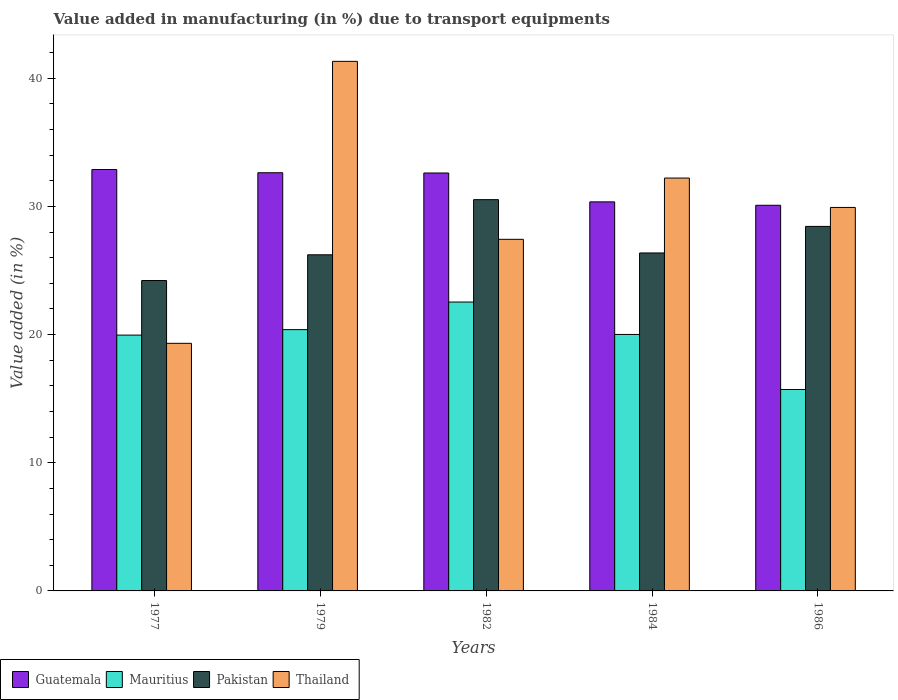How many different coloured bars are there?
Offer a very short reply. 4. How many groups of bars are there?
Offer a terse response. 5. Are the number of bars on each tick of the X-axis equal?
Offer a terse response. Yes. How many bars are there on the 2nd tick from the left?
Ensure brevity in your answer.  4. In how many cases, is the number of bars for a given year not equal to the number of legend labels?
Offer a very short reply. 0. What is the percentage of value added in manufacturing due to transport equipments in Mauritius in 1977?
Give a very brief answer. 19.96. Across all years, what is the maximum percentage of value added in manufacturing due to transport equipments in Guatemala?
Offer a very short reply. 32.88. Across all years, what is the minimum percentage of value added in manufacturing due to transport equipments in Guatemala?
Ensure brevity in your answer.  30.09. In which year was the percentage of value added in manufacturing due to transport equipments in Pakistan minimum?
Your response must be concise. 1977. What is the total percentage of value added in manufacturing due to transport equipments in Thailand in the graph?
Offer a terse response. 150.21. What is the difference between the percentage of value added in manufacturing due to transport equipments in Guatemala in 1977 and that in 1984?
Your answer should be very brief. 2.53. What is the difference between the percentage of value added in manufacturing due to transport equipments in Mauritius in 1977 and the percentage of value added in manufacturing due to transport equipments in Pakistan in 1984?
Offer a very short reply. -6.41. What is the average percentage of value added in manufacturing due to transport equipments in Mauritius per year?
Give a very brief answer. 19.72. In the year 1979, what is the difference between the percentage of value added in manufacturing due to transport equipments in Pakistan and percentage of value added in manufacturing due to transport equipments in Guatemala?
Keep it short and to the point. -6.4. What is the ratio of the percentage of value added in manufacturing due to transport equipments in Pakistan in 1982 to that in 1986?
Keep it short and to the point. 1.07. Is the percentage of value added in manufacturing due to transport equipments in Pakistan in 1979 less than that in 1982?
Provide a succinct answer. Yes. What is the difference between the highest and the second highest percentage of value added in manufacturing due to transport equipments in Mauritius?
Provide a short and direct response. 2.15. What is the difference between the highest and the lowest percentage of value added in manufacturing due to transport equipments in Guatemala?
Your answer should be compact. 2.79. In how many years, is the percentage of value added in manufacturing due to transport equipments in Mauritius greater than the average percentage of value added in manufacturing due to transport equipments in Mauritius taken over all years?
Provide a short and direct response. 4. What does the 4th bar from the left in 1977 represents?
Your response must be concise. Thailand. What does the 1st bar from the right in 1979 represents?
Offer a very short reply. Thailand. How many bars are there?
Your answer should be compact. 20. Are all the bars in the graph horizontal?
Your response must be concise. No. Are the values on the major ticks of Y-axis written in scientific E-notation?
Your response must be concise. No. Does the graph contain any zero values?
Make the answer very short. No. Does the graph contain grids?
Ensure brevity in your answer.  No. How are the legend labels stacked?
Ensure brevity in your answer.  Horizontal. What is the title of the graph?
Offer a terse response. Value added in manufacturing (in %) due to transport equipments. Does "Gambia, The" appear as one of the legend labels in the graph?
Offer a very short reply. No. What is the label or title of the X-axis?
Your answer should be very brief. Years. What is the label or title of the Y-axis?
Your response must be concise. Value added (in %). What is the Value added (in %) in Guatemala in 1977?
Your response must be concise. 32.88. What is the Value added (in %) in Mauritius in 1977?
Offer a very short reply. 19.96. What is the Value added (in %) in Pakistan in 1977?
Give a very brief answer. 24.22. What is the Value added (in %) of Thailand in 1977?
Provide a short and direct response. 19.32. What is the Value added (in %) of Guatemala in 1979?
Provide a short and direct response. 32.63. What is the Value added (in %) of Mauritius in 1979?
Provide a short and direct response. 20.39. What is the Value added (in %) in Pakistan in 1979?
Offer a terse response. 26.23. What is the Value added (in %) in Thailand in 1979?
Offer a terse response. 41.32. What is the Value added (in %) in Guatemala in 1982?
Give a very brief answer. 32.61. What is the Value added (in %) of Mauritius in 1982?
Give a very brief answer. 22.54. What is the Value added (in %) in Pakistan in 1982?
Provide a short and direct response. 30.53. What is the Value added (in %) in Thailand in 1982?
Give a very brief answer. 27.43. What is the Value added (in %) of Guatemala in 1984?
Offer a terse response. 30.36. What is the Value added (in %) of Mauritius in 1984?
Provide a short and direct response. 20.01. What is the Value added (in %) of Pakistan in 1984?
Offer a terse response. 26.37. What is the Value added (in %) of Thailand in 1984?
Provide a short and direct response. 32.21. What is the Value added (in %) in Guatemala in 1986?
Ensure brevity in your answer.  30.09. What is the Value added (in %) in Mauritius in 1986?
Ensure brevity in your answer.  15.72. What is the Value added (in %) in Pakistan in 1986?
Keep it short and to the point. 28.44. What is the Value added (in %) of Thailand in 1986?
Provide a succinct answer. 29.92. Across all years, what is the maximum Value added (in %) of Guatemala?
Your response must be concise. 32.88. Across all years, what is the maximum Value added (in %) in Mauritius?
Keep it short and to the point. 22.54. Across all years, what is the maximum Value added (in %) in Pakistan?
Provide a short and direct response. 30.53. Across all years, what is the maximum Value added (in %) of Thailand?
Ensure brevity in your answer.  41.32. Across all years, what is the minimum Value added (in %) in Guatemala?
Your answer should be compact. 30.09. Across all years, what is the minimum Value added (in %) of Mauritius?
Your answer should be very brief. 15.72. Across all years, what is the minimum Value added (in %) of Pakistan?
Offer a very short reply. 24.22. Across all years, what is the minimum Value added (in %) in Thailand?
Ensure brevity in your answer.  19.32. What is the total Value added (in %) of Guatemala in the graph?
Your response must be concise. 158.57. What is the total Value added (in %) of Mauritius in the graph?
Provide a succinct answer. 98.61. What is the total Value added (in %) of Pakistan in the graph?
Your answer should be very brief. 135.79. What is the total Value added (in %) of Thailand in the graph?
Offer a terse response. 150.21. What is the difference between the Value added (in %) of Guatemala in 1977 and that in 1979?
Provide a succinct answer. 0.25. What is the difference between the Value added (in %) in Mauritius in 1977 and that in 1979?
Your response must be concise. -0.43. What is the difference between the Value added (in %) in Pakistan in 1977 and that in 1979?
Keep it short and to the point. -2.01. What is the difference between the Value added (in %) of Thailand in 1977 and that in 1979?
Ensure brevity in your answer.  -22. What is the difference between the Value added (in %) of Guatemala in 1977 and that in 1982?
Offer a very short reply. 0.27. What is the difference between the Value added (in %) of Mauritius in 1977 and that in 1982?
Your response must be concise. -2.58. What is the difference between the Value added (in %) of Pakistan in 1977 and that in 1982?
Your answer should be compact. -6.31. What is the difference between the Value added (in %) of Thailand in 1977 and that in 1982?
Give a very brief answer. -8.11. What is the difference between the Value added (in %) in Guatemala in 1977 and that in 1984?
Provide a succinct answer. 2.53. What is the difference between the Value added (in %) in Mauritius in 1977 and that in 1984?
Offer a terse response. -0.05. What is the difference between the Value added (in %) in Pakistan in 1977 and that in 1984?
Give a very brief answer. -2.15. What is the difference between the Value added (in %) of Thailand in 1977 and that in 1984?
Offer a terse response. -12.89. What is the difference between the Value added (in %) of Guatemala in 1977 and that in 1986?
Offer a very short reply. 2.79. What is the difference between the Value added (in %) in Mauritius in 1977 and that in 1986?
Your answer should be compact. 4.24. What is the difference between the Value added (in %) in Pakistan in 1977 and that in 1986?
Ensure brevity in your answer.  -4.22. What is the difference between the Value added (in %) in Thailand in 1977 and that in 1986?
Your answer should be compact. -10.6. What is the difference between the Value added (in %) of Guatemala in 1979 and that in 1982?
Your response must be concise. 0.02. What is the difference between the Value added (in %) of Mauritius in 1979 and that in 1982?
Your response must be concise. -2.15. What is the difference between the Value added (in %) of Pakistan in 1979 and that in 1982?
Ensure brevity in your answer.  -4.3. What is the difference between the Value added (in %) in Thailand in 1979 and that in 1982?
Your response must be concise. 13.89. What is the difference between the Value added (in %) of Guatemala in 1979 and that in 1984?
Give a very brief answer. 2.27. What is the difference between the Value added (in %) of Mauritius in 1979 and that in 1984?
Make the answer very short. 0.38. What is the difference between the Value added (in %) in Pakistan in 1979 and that in 1984?
Keep it short and to the point. -0.14. What is the difference between the Value added (in %) of Thailand in 1979 and that in 1984?
Offer a terse response. 9.11. What is the difference between the Value added (in %) in Guatemala in 1979 and that in 1986?
Your answer should be compact. 2.54. What is the difference between the Value added (in %) in Mauritius in 1979 and that in 1986?
Your response must be concise. 4.67. What is the difference between the Value added (in %) in Pakistan in 1979 and that in 1986?
Your answer should be compact. -2.21. What is the difference between the Value added (in %) of Thailand in 1979 and that in 1986?
Keep it short and to the point. 11.4. What is the difference between the Value added (in %) in Guatemala in 1982 and that in 1984?
Your answer should be compact. 2.25. What is the difference between the Value added (in %) in Mauritius in 1982 and that in 1984?
Keep it short and to the point. 2.53. What is the difference between the Value added (in %) of Pakistan in 1982 and that in 1984?
Offer a very short reply. 4.16. What is the difference between the Value added (in %) of Thailand in 1982 and that in 1984?
Give a very brief answer. -4.78. What is the difference between the Value added (in %) in Guatemala in 1982 and that in 1986?
Keep it short and to the point. 2.52. What is the difference between the Value added (in %) of Mauritius in 1982 and that in 1986?
Give a very brief answer. 6.82. What is the difference between the Value added (in %) of Pakistan in 1982 and that in 1986?
Offer a very short reply. 2.09. What is the difference between the Value added (in %) in Thailand in 1982 and that in 1986?
Your answer should be compact. -2.49. What is the difference between the Value added (in %) in Guatemala in 1984 and that in 1986?
Your answer should be very brief. 0.27. What is the difference between the Value added (in %) in Mauritius in 1984 and that in 1986?
Your answer should be compact. 4.3. What is the difference between the Value added (in %) of Pakistan in 1984 and that in 1986?
Ensure brevity in your answer.  -2.07. What is the difference between the Value added (in %) in Thailand in 1984 and that in 1986?
Ensure brevity in your answer.  2.29. What is the difference between the Value added (in %) of Guatemala in 1977 and the Value added (in %) of Mauritius in 1979?
Make the answer very short. 12.49. What is the difference between the Value added (in %) in Guatemala in 1977 and the Value added (in %) in Pakistan in 1979?
Provide a short and direct response. 6.65. What is the difference between the Value added (in %) of Guatemala in 1977 and the Value added (in %) of Thailand in 1979?
Provide a succinct answer. -8.44. What is the difference between the Value added (in %) in Mauritius in 1977 and the Value added (in %) in Pakistan in 1979?
Offer a terse response. -6.27. What is the difference between the Value added (in %) in Mauritius in 1977 and the Value added (in %) in Thailand in 1979?
Provide a succinct answer. -21.36. What is the difference between the Value added (in %) in Pakistan in 1977 and the Value added (in %) in Thailand in 1979?
Offer a very short reply. -17.1. What is the difference between the Value added (in %) in Guatemala in 1977 and the Value added (in %) in Mauritius in 1982?
Keep it short and to the point. 10.34. What is the difference between the Value added (in %) in Guatemala in 1977 and the Value added (in %) in Pakistan in 1982?
Give a very brief answer. 2.35. What is the difference between the Value added (in %) of Guatemala in 1977 and the Value added (in %) of Thailand in 1982?
Make the answer very short. 5.45. What is the difference between the Value added (in %) in Mauritius in 1977 and the Value added (in %) in Pakistan in 1982?
Keep it short and to the point. -10.57. What is the difference between the Value added (in %) in Mauritius in 1977 and the Value added (in %) in Thailand in 1982?
Provide a succinct answer. -7.47. What is the difference between the Value added (in %) of Pakistan in 1977 and the Value added (in %) of Thailand in 1982?
Offer a terse response. -3.21. What is the difference between the Value added (in %) of Guatemala in 1977 and the Value added (in %) of Mauritius in 1984?
Offer a very short reply. 12.87. What is the difference between the Value added (in %) of Guatemala in 1977 and the Value added (in %) of Pakistan in 1984?
Provide a short and direct response. 6.51. What is the difference between the Value added (in %) in Guatemala in 1977 and the Value added (in %) in Thailand in 1984?
Make the answer very short. 0.67. What is the difference between the Value added (in %) of Mauritius in 1977 and the Value added (in %) of Pakistan in 1984?
Your response must be concise. -6.41. What is the difference between the Value added (in %) of Mauritius in 1977 and the Value added (in %) of Thailand in 1984?
Offer a terse response. -12.25. What is the difference between the Value added (in %) of Pakistan in 1977 and the Value added (in %) of Thailand in 1984?
Keep it short and to the point. -7.99. What is the difference between the Value added (in %) in Guatemala in 1977 and the Value added (in %) in Mauritius in 1986?
Provide a short and direct response. 17.17. What is the difference between the Value added (in %) of Guatemala in 1977 and the Value added (in %) of Pakistan in 1986?
Give a very brief answer. 4.44. What is the difference between the Value added (in %) in Guatemala in 1977 and the Value added (in %) in Thailand in 1986?
Offer a terse response. 2.96. What is the difference between the Value added (in %) of Mauritius in 1977 and the Value added (in %) of Pakistan in 1986?
Provide a short and direct response. -8.48. What is the difference between the Value added (in %) in Mauritius in 1977 and the Value added (in %) in Thailand in 1986?
Your answer should be compact. -9.96. What is the difference between the Value added (in %) in Pakistan in 1977 and the Value added (in %) in Thailand in 1986?
Your answer should be very brief. -5.7. What is the difference between the Value added (in %) in Guatemala in 1979 and the Value added (in %) in Mauritius in 1982?
Give a very brief answer. 10.09. What is the difference between the Value added (in %) in Guatemala in 1979 and the Value added (in %) in Pakistan in 1982?
Ensure brevity in your answer.  2.1. What is the difference between the Value added (in %) in Guatemala in 1979 and the Value added (in %) in Thailand in 1982?
Provide a short and direct response. 5.2. What is the difference between the Value added (in %) of Mauritius in 1979 and the Value added (in %) of Pakistan in 1982?
Keep it short and to the point. -10.14. What is the difference between the Value added (in %) of Mauritius in 1979 and the Value added (in %) of Thailand in 1982?
Offer a terse response. -7.05. What is the difference between the Value added (in %) in Pakistan in 1979 and the Value added (in %) in Thailand in 1982?
Your answer should be compact. -1.21. What is the difference between the Value added (in %) in Guatemala in 1979 and the Value added (in %) in Mauritius in 1984?
Offer a very short reply. 12.62. What is the difference between the Value added (in %) in Guatemala in 1979 and the Value added (in %) in Pakistan in 1984?
Your response must be concise. 6.26. What is the difference between the Value added (in %) in Guatemala in 1979 and the Value added (in %) in Thailand in 1984?
Your response must be concise. 0.41. What is the difference between the Value added (in %) of Mauritius in 1979 and the Value added (in %) of Pakistan in 1984?
Make the answer very short. -5.98. What is the difference between the Value added (in %) of Mauritius in 1979 and the Value added (in %) of Thailand in 1984?
Offer a very short reply. -11.83. What is the difference between the Value added (in %) in Pakistan in 1979 and the Value added (in %) in Thailand in 1984?
Your answer should be compact. -5.99. What is the difference between the Value added (in %) in Guatemala in 1979 and the Value added (in %) in Mauritius in 1986?
Offer a terse response. 16.91. What is the difference between the Value added (in %) of Guatemala in 1979 and the Value added (in %) of Pakistan in 1986?
Offer a terse response. 4.19. What is the difference between the Value added (in %) in Guatemala in 1979 and the Value added (in %) in Thailand in 1986?
Your answer should be compact. 2.71. What is the difference between the Value added (in %) of Mauritius in 1979 and the Value added (in %) of Pakistan in 1986?
Offer a terse response. -8.05. What is the difference between the Value added (in %) in Mauritius in 1979 and the Value added (in %) in Thailand in 1986?
Make the answer very short. -9.53. What is the difference between the Value added (in %) in Pakistan in 1979 and the Value added (in %) in Thailand in 1986?
Keep it short and to the point. -3.69. What is the difference between the Value added (in %) of Guatemala in 1982 and the Value added (in %) of Mauritius in 1984?
Give a very brief answer. 12.6. What is the difference between the Value added (in %) in Guatemala in 1982 and the Value added (in %) in Pakistan in 1984?
Give a very brief answer. 6.24. What is the difference between the Value added (in %) of Guatemala in 1982 and the Value added (in %) of Thailand in 1984?
Your answer should be compact. 0.4. What is the difference between the Value added (in %) of Mauritius in 1982 and the Value added (in %) of Pakistan in 1984?
Your answer should be very brief. -3.83. What is the difference between the Value added (in %) in Mauritius in 1982 and the Value added (in %) in Thailand in 1984?
Keep it short and to the point. -9.67. What is the difference between the Value added (in %) of Pakistan in 1982 and the Value added (in %) of Thailand in 1984?
Your response must be concise. -1.68. What is the difference between the Value added (in %) of Guatemala in 1982 and the Value added (in %) of Mauritius in 1986?
Provide a short and direct response. 16.89. What is the difference between the Value added (in %) of Guatemala in 1982 and the Value added (in %) of Pakistan in 1986?
Offer a very short reply. 4.17. What is the difference between the Value added (in %) in Guatemala in 1982 and the Value added (in %) in Thailand in 1986?
Provide a short and direct response. 2.69. What is the difference between the Value added (in %) of Mauritius in 1982 and the Value added (in %) of Pakistan in 1986?
Offer a terse response. -5.9. What is the difference between the Value added (in %) of Mauritius in 1982 and the Value added (in %) of Thailand in 1986?
Keep it short and to the point. -7.38. What is the difference between the Value added (in %) of Pakistan in 1982 and the Value added (in %) of Thailand in 1986?
Give a very brief answer. 0.61. What is the difference between the Value added (in %) in Guatemala in 1984 and the Value added (in %) in Mauritius in 1986?
Give a very brief answer. 14.64. What is the difference between the Value added (in %) in Guatemala in 1984 and the Value added (in %) in Pakistan in 1986?
Keep it short and to the point. 1.91. What is the difference between the Value added (in %) in Guatemala in 1984 and the Value added (in %) in Thailand in 1986?
Provide a succinct answer. 0.44. What is the difference between the Value added (in %) of Mauritius in 1984 and the Value added (in %) of Pakistan in 1986?
Provide a succinct answer. -8.43. What is the difference between the Value added (in %) in Mauritius in 1984 and the Value added (in %) in Thailand in 1986?
Provide a succinct answer. -9.91. What is the difference between the Value added (in %) in Pakistan in 1984 and the Value added (in %) in Thailand in 1986?
Offer a very short reply. -3.55. What is the average Value added (in %) of Guatemala per year?
Your response must be concise. 31.71. What is the average Value added (in %) in Mauritius per year?
Provide a short and direct response. 19.72. What is the average Value added (in %) in Pakistan per year?
Give a very brief answer. 27.16. What is the average Value added (in %) of Thailand per year?
Your answer should be very brief. 30.04. In the year 1977, what is the difference between the Value added (in %) of Guatemala and Value added (in %) of Mauritius?
Offer a terse response. 12.92. In the year 1977, what is the difference between the Value added (in %) of Guatemala and Value added (in %) of Pakistan?
Ensure brevity in your answer.  8.66. In the year 1977, what is the difference between the Value added (in %) of Guatemala and Value added (in %) of Thailand?
Provide a short and direct response. 13.56. In the year 1977, what is the difference between the Value added (in %) in Mauritius and Value added (in %) in Pakistan?
Offer a very short reply. -4.26. In the year 1977, what is the difference between the Value added (in %) of Mauritius and Value added (in %) of Thailand?
Make the answer very short. 0.64. In the year 1977, what is the difference between the Value added (in %) in Pakistan and Value added (in %) in Thailand?
Offer a terse response. 4.9. In the year 1979, what is the difference between the Value added (in %) of Guatemala and Value added (in %) of Mauritius?
Your answer should be very brief. 12.24. In the year 1979, what is the difference between the Value added (in %) in Guatemala and Value added (in %) in Pakistan?
Ensure brevity in your answer.  6.4. In the year 1979, what is the difference between the Value added (in %) in Guatemala and Value added (in %) in Thailand?
Give a very brief answer. -8.69. In the year 1979, what is the difference between the Value added (in %) of Mauritius and Value added (in %) of Pakistan?
Give a very brief answer. -5.84. In the year 1979, what is the difference between the Value added (in %) in Mauritius and Value added (in %) in Thailand?
Provide a succinct answer. -20.93. In the year 1979, what is the difference between the Value added (in %) of Pakistan and Value added (in %) of Thailand?
Offer a very short reply. -15.09. In the year 1982, what is the difference between the Value added (in %) of Guatemala and Value added (in %) of Mauritius?
Provide a succinct answer. 10.07. In the year 1982, what is the difference between the Value added (in %) in Guatemala and Value added (in %) in Pakistan?
Ensure brevity in your answer.  2.08. In the year 1982, what is the difference between the Value added (in %) of Guatemala and Value added (in %) of Thailand?
Keep it short and to the point. 5.18. In the year 1982, what is the difference between the Value added (in %) of Mauritius and Value added (in %) of Pakistan?
Make the answer very short. -7.99. In the year 1982, what is the difference between the Value added (in %) of Mauritius and Value added (in %) of Thailand?
Offer a terse response. -4.89. In the year 1982, what is the difference between the Value added (in %) in Pakistan and Value added (in %) in Thailand?
Your response must be concise. 3.1. In the year 1984, what is the difference between the Value added (in %) of Guatemala and Value added (in %) of Mauritius?
Make the answer very short. 10.34. In the year 1984, what is the difference between the Value added (in %) in Guatemala and Value added (in %) in Pakistan?
Provide a succinct answer. 3.99. In the year 1984, what is the difference between the Value added (in %) of Guatemala and Value added (in %) of Thailand?
Your response must be concise. -1.86. In the year 1984, what is the difference between the Value added (in %) in Mauritius and Value added (in %) in Pakistan?
Offer a very short reply. -6.36. In the year 1984, what is the difference between the Value added (in %) of Mauritius and Value added (in %) of Thailand?
Provide a succinct answer. -12.2. In the year 1984, what is the difference between the Value added (in %) in Pakistan and Value added (in %) in Thailand?
Your answer should be compact. -5.84. In the year 1986, what is the difference between the Value added (in %) in Guatemala and Value added (in %) in Mauritius?
Offer a very short reply. 14.37. In the year 1986, what is the difference between the Value added (in %) of Guatemala and Value added (in %) of Pakistan?
Provide a succinct answer. 1.65. In the year 1986, what is the difference between the Value added (in %) in Guatemala and Value added (in %) in Thailand?
Offer a terse response. 0.17. In the year 1986, what is the difference between the Value added (in %) of Mauritius and Value added (in %) of Pakistan?
Make the answer very short. -12.73. In the year 1986, what is the difference between the Value added (in %) of Mauritius and Value added (in %) of Thailand?
Your response must be concise. -14.21. In the year 1986, what is the difference between the Value added (in %) of Pakistan and Value added (in %) of Thailand?
Offer a very short reply. -1.48. What is the ratio of the Value added (in %) in Guatemala in 1977 to that in 1979?
Provide a succinct answer. 1.01. What is the ratio of the Value added (in %) in Mauritius in 1977 to that in 1979?
Your answer should be compact. 0.98. What is the ratio of the Value added (in %) of Pakistan in 1977 to that in 1979?
Provide a short and direct response. 0.92. What is the ratio of the Value added (in %) of Thailand in 1977 to that in 1979?
Give a very brief answer. 0.47. What is the ratio of the Value added (in %) of Guatemala in 1977 to that in 1982?
Your response must be concise. 1.01. What is the ratio of the Value added (in %) in Mauritius in 1977 to that in 1982?
Keep it short and to the point. 0.89. What is the ratio of the Value added (in %) in Pakistan in 1977 to that in 1982?
Your response must be concise. 0.79. What is the ratio of the Value added (in %) in Thailand in 1977 to that in 1982?
Your answer should be very brief. 0.7. What is the ratio of the Value added (in %) of Guatemala in 1977 to that in 1984?
Offer a very short reply. 1.08. What is the ratio of the Value added (in %) in Pakistan in 1977 to that in 1984?
Give a very brief answer. 0.92. What is the ratio of the Value added (in %) in Thailand in 1977 to that in 1984?
Offer a terse response. 0.6. What is the ratio of the Value added (in %) of Guatemala in 1977 to that in 1986?
Your answer should be compact. 1.09. What is the ratio of the Value added (in %) of Mauritius in 1977 to that in 1986?
Provide a succinct answer. 1.27. What is the ratio of the Value added (in %) of Pakistan in 1977 to that in 1986?
Your answer should be compact. 0.85. What is the ratio of the Value added (in %) of Thailand in 1977 to that in 1986?
Keep it short and to the point. 0.65. What is the ratio of the Value added (in %) in Guatemala in 1979 to that in 1982?
Offer a very short reply. 1. What is the ratio of the Value added (in %) in Mauritius in 1979 to that in 1982?
Your response must be concise. 0.9. What is the ratio of the Value added (in %) of Pakistan in 1979 to that in 1982?
Your answer should be compact. 0.86. What is the ratio of the Value added (in %) of Thailand in 1979 to that in 1982?
Give a very brief answer. 1.51. What is the ratio of the Value added (in %) in Guatemala in 1979 to that in 1984?
Make the answer very short. 1.07. What is the ratio of the Value added (in %) of Mauritius in 1979 to that in 1984?
Give a very brief answer. 1.02. What is the ratio of the Value added (in %) of Thailand in 1979 to that in 1984?
Keep it short and to the point. 1.28. What is the ratio of the Value added (in %) of Guatemala in 1979 to that in 1986?
Provide a succinct answer. 1.08. What is the ratio of the Value added (in %) in Mauritius in 1979 to that in 1986?
Your response must be concise. 1.3. What is the ratio of the Value added (in %) of Pakistan in 1979 to that in 1986?
Offer a terse response. 0.92. What is the ratio of the Value added (in %) in Thailand in 1979 to that in 1986?
Provide a succinct answer. 1.38. What is the ratio of the Value added (in %) of Guatemala in 1982 to that in 1984?
Offer a terse response. 1.07. What is the ratio of the Value added (in %) of Mauritius in 1982 to that in 1984?
Offer a terse response. 1.13. What is the ratio of the Value added (in %) of Pakistan in 1982 to that in 1984?
Your response must be concise. 1.16. What is the ratio of the Value added (in %) of Thailand in 1982 to that in 1984?
Give a very brief answer. 0.85. What is the ratio of the Value added (in %) of Guatemala in 1982 to that in 1986?
Keep it short and to the point. 1.08. What is the ratio of the Value added (in %) in Mauritius in 1982 to that in 1986?
Offer a terse response. 1.43. What is the ratio of the Value added (in %) in Pakistan in 1982 to that in 1986?
Make the answer very short. 1.07. What is the ratio of the Value added (in %) in Thailand in 1982 to that in 1986?
Provide a succinct answer. 0.92. What is the ratio of the Value added (in %) of Guatemala in 1984 to that in 1986?
Offer a very short reply. 1.01. What is the ratio of the Value added (in %) of Mauritius in 1984 to that in 1986?
Offer a very short reply. 1.27. What is the ratio of the Value added (in %) of Pakistan in 1984 to that in 1986?
Provide a succinct answer. 0.93. What is the ratio of the Value added (in %) of Thailand in 1984 to that in 1986?
Provide a short and direct response. 1.08. What is the difference between the highest and the second highest Value added (in %) in Guatemala?
Your response must be concise. 0.25. What is the difference between the highest and the second highest Value added (in %) in Mauritius?
Keep it short and to the point. 2.15. What is the difference between the highest and the second highest Value added (in %) in Pakistan?
Provide a short and direct response. 2.09. What is the difference between the highest and the second highest Value added (in %) in Thailand?
Make the answer very short. 9.11. What is the difference between the highest and the lowest Value added (in %) in Guatemala?
Your response must be concise. 2.79. What is the difference between the highest and the lowest Value added (in %) of Mauritius?
Your answer should be compact. 6.82. What is the difference between the highest and the lowest Value added (in %) in Pakistan?
Offer a very short reply. 6.31. What is the difference between the highest and the lowest Value added (in %) in Thailand?
Provide a short and direct response. 22. 